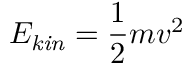Convert formula to latex. <formula><loc_0><loc_0><loc_500><loc_500>E _ { k i n } = { \frac { 1 } { 2 } } m v ^ { 2 }</formula> 